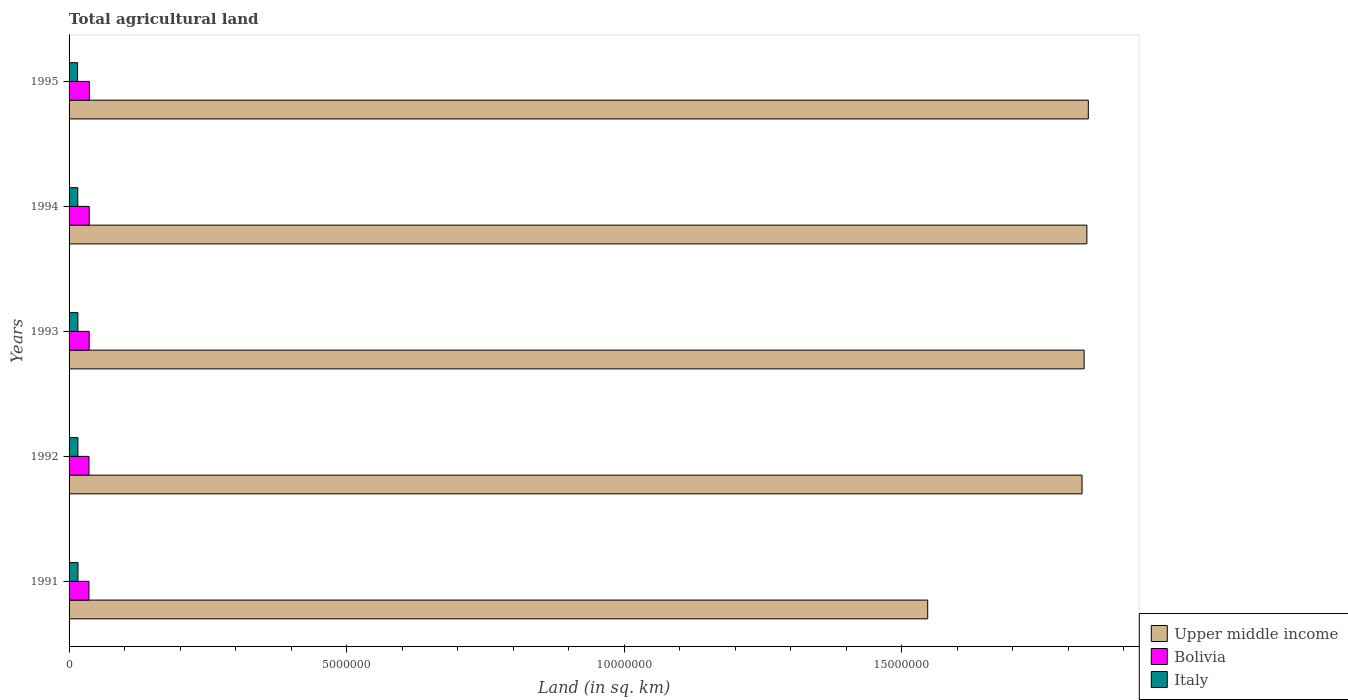How many different coloured bars are there?
Your response must be concise. 3. Are the number of bars on each tick of the Y-axis equal?
Offer a terse response. Yes. In how many cases, is the number of bars for a given year not equal to the number of legend labels?
Your answer should be compact. 0. What is the total agricultural land in Bolivia in 1992?
Offer a terse response. 3.58e+05. Across all years, what is the maximum total agricultural land in Italy?
Offer a very short reply. 1.61e+05. Across all years, what is the minimum total agricultural land in Italy?
Provide a succinct answer. 1.53e+05. In which year was the total agricultural land in Upper middle income maximum?
Your response must be concise. 1995. What is the total total agricultural land in Italy in the graph?
Offer a terse response. 7.90e+05. What is the difference between the total agricultural land in Bolivia in 1994 and that in 1995?
Offer a very short reply. -2490. What is the difference between the total agricultural land in Italy in 1993 and the total agricultural land in Upper middle income in 1994?
Offer a very short reply. -1.82e+07. What is the average total agricultural land in Italy per year?
Keep it short and to the point. 1.58e+05. In the year 1995, what is the difference between the total agricultural land in Upper middle income and total agricultural land in Bolivia?
Provide a short and direct response. 1.80e+07. In how many years, is the total agricultural land in Bolivia greater than 6000000 sq.km?
Ensure brevity in your answer.  0. What is the ratio of the total agricultural land in Bolivia in 1994 to that in 1995?
Your answer should be very brief. 0.99. Is the total agricultural land in Bolivia in 1992 less than that in 1993?
Provide a succinct answer. Yes. What is the difference between the highest and the second highest total agricultural land in Upper middle income?
Your answer should be compact. 2.58e+04. What is the difference between the highest and the lowest total agricultural land in Upper middle income?
Provide a short and direct response. 2.89e+06. Is the sum of the total agricultural land in Upper middle income in 1994 and 1995 greater than the maximum total agricultural land in Italy across all years?
Your response must be concise. Yes. What does the 1st bar from the top in 1992 represents?
Your response must be concise. Italy. Is it the case that in every year, the sum of the total agricultural land in Bolivia and total agricultural land in Italy is greater than the total agricultural land in Upper middle income?
Make the answer very short. No. Are all the bars in the graph horizontal?
Make the answer very short. Yes. What is the difference between two consecutive major ticks on the X-axis?
Your answer should be very brief. 5.00e+06. What is the title of the graph?
Your answer should be compact. Total agricultural land. Does "Myanmar" appear as one of the legend labels in the graph?
Your answer should be very brief. No. What is the label or title of the X-axis?
Provide a short and direct response. Land (in sq. km). What is the label or title of the Y-axis?
Make the answer very short. Years. What is the Land (in sq. km) of Upper middle income in 1991?
Make the answer very short. 1.55e+07. What is the Land (in sq. km) of Bolivia in 1991?
Provide a succinct answer. 3.58e+05. What is the Land (in sq. km) in Italy in 1991?
Your answer should be very brief. 1.61e+05. What is the Land (in sq. km) of Upper middle income in 1992?
Your answer should be very brief. 1.82e+07. What is the Land (in sq. km) of Bolivia in 1992?
Offer a terse response. 3.58e+05. What is the Land (in sq. km) in Italy in 1992?
Keep it short and to the point. 1.60e+05. What is the Land (in sq. km) of Upper middle income in 1993?
Your answer should be very brief. 1.83e+07. What is the Land (in sq. km) in Bolivia in 1993?
Your response must be concise. 3.62e+05. What is the Land (in sq. km) in Italy in 1993?
Your response must be concise. 1.59e+05. What is the Land (in sq. km) of Upper middle income in 1994?
Provide a short and direct response. 1.83e+07. What is the Land (in sq. km) of Bolivia in 1994?
Make the answer very short. 3.64e+05. What is the Land (in sq. km) in Italy in 1994?
Give a very brief answer. 1.57e+05. What is the Land (in sq. km) in Upper middle income in 1995?
Your response must be concise. 1.84e+07. What is the Land (in sq. km) in Bolivia in 1995?
Keep it short and to the point. 3.66e+05. What is the Land (in sq. km) in Italy in 1995?
Provide a succinct answer. 1.53e+05. Across all years, what is the maximum Land (in sq. km) in Upper middle income?
Keep it short and to the point. 1.84e+07. Across all years, what is the maximum Land (in sq. km) of Bolivia?
Your answer should be very brief. 3.66e+05. Across all years, what is the maximum Land (in sq. km) in Italy?
Your answer should be very brief. 1.61e+05. Across all years, what is the minimum Land (in sq. km) of Upper middle income?
Your answer should be compact. 1.55e+07. Across all years, what is the minimum Land (in sq. km) of Bolivia?
Your response must be concise. 3.58e+05. Across all years, what is the minimum Land (in sq. km) of Italy?
Make the answer very short. 1.53e+05. What is the total Land (in sq. km) in Upper middle income in the graph?
Your answer should be very brief. 8.87e+07. What is the total Land (in sq. km) in Bolivia in the graph?
Make the answer very short. 1.81e+06. What is the total Land (in sq. km) in Italy in the graph?
Your answer should be compact. 7.90e+05. What is the difference between the Land (in sq. km) of Upper middle income in 1991 and that in 1992?
Make the answer very short. -2.78e+06. What is the difference between the Land (in sq. km) in Bolivia in 1991 and that in 1992?
Offer a very short reply. -350. What is the difference between the Land (in sq. km) in Italy in 1991 and that in 1992?
Provide a short and direct response. 760. What is the difference between the Land (in sq. km) in Upper middle income in 1991 and that in 1993?
Ensure brevity in your answer.  -2.82e+06. What is the difference between the Land (in sq. km) of Bolivia in 1991 and that in 1993?
Provide a short and direct response. -4170. What is the difference between the Land (in sq. km) of Italy in 1991 and that in 1993?
Provide a succinct answer. 1440. What is the difference between the Land (in sq. km) of Upper middle income in 1991 and that in 1994?
Offer a terse response. -2.87e+06. What is the difference between the Land (in sq. km) of Bolivia in 1991 and that in 1994?
Keep it short and to the point. -5550. What is the difference between the Land (in sq. km) in Italy in 1991 and that in 1994?
Provide a succinct answer. 3520. What is the difference between the Land (in sq. km) in Upper middle income in 1991 and that in 1995?
Offer a very short reply. -2.89e+06. What is the difference between the Land (in sq. km) in Bolivia in 1991 and that in 1995?
Offer a terse response. -8040. What is the difference between the Land (in sq. km) of Italy in 1991 and that in 1995?
Your response must be concise. 7210. What is the difference between the Land (in sq. km) in Upper middle income in 1992 and that in 1993?
Offer a very short reply. -3.69e+04. What is the difference between the Land (in sq. km) of Bolivia in 1992 and that in 1993?
Make the answer very short. -3820. What is the difference between the Land (in sq. km) of Italy in 1992 and that in 1993?
Your answer should be very brief. 680. What is the difference between the Land (in sq. km) in Upper middle income in 1992 and that in 1994?
Give a very brief answer. -8.69e+04. What is the difference between the Land (in sq. km) in Bolivia in 1992 and that in 1994?
Keep it short and to the point. -5200. What is the difference between the Land (in sq. km) in Italy in 1992 and that in 1994?
Make the answer very short. 2760. What is the difference between the Land (in sq. km) in Upper middle income in 1992 and that in 1995?
Your answer should be compact. -1.13e+05. What is the difference between the Land (in sq. km) in Bolivia in 1992 and that in 1995?
Make the answer very short. -7690. What is the difference between the Land (in sq. km) in Italy in 1992 and that in 1995?
Give a very brief answer. 6450. What is the difference between the Land (in sq. km) of Upper middle income in 1993 and that in 1994?
Make the answer very short. -5.00e+04. What is the difference between the Land (in sq. km) in Bolivia in 1993 and that in 1994?
Provide a short and direct response. -1380. What is the difference between the Land (in sq. km) of Italy in 1993 and that in 1994?
Provide a short and direct response. 2080. What is the difference between the Land (in sq. km) in Upper middle income in 1993 and that in 1995?
Your answer should be compact. -7.58e+04. What is the difference between the Land (in sq. km) in Bolivia in 1993 and that in 1995?
Your answer should be compact. -3870. What is the difference between the Land (in sq. km) of Italy in 1993 and that in 1995?
Offer a very short reply. 5770. What is the difference between the Land (in sq. km) of Upper middle income in 1994 and that in 1995?
Your answer should be very brief. -2.58e+04. What is the difference between the Land (in sq. km) of Bolivia in 1994 and that in 1995?
Offer a very short reply. -2490. What is the difference between the Land (in sq. km) of Italy in 1994 and that in 1995?
Your answer should be compact. 3690. What is the difference between the Land (in sq. km) of Upper middle income in 1991 and the Land (in sq. km) of Bolivia in 1992?
Offer a terse response. 1.51e+07. What is the difference between the Land (in sq. km) of Upper middle income in 1991 and the Land (in sq. km) of Italy in 1992?
Your answer should be very brief. 1.53e+07. What is the difference between the Land (in sq. km) of Bolivia in 1991 and the Land (in sq. km) of Italy in 1992?
Provide a short and direct response. 1.98e+05. What is the difference between the Land (in sq. km) in Upper middle income in 1991 and the Land (in sq. km) in Bolivia in 1993?
Give a very brief answer. 1.51e+07. What is the difference between the Land (in sq. km) of Upper middle income in 1991 and the Land (in sq. km) of Italy in 1993?
Provide a succinct answer. 1.53e+07. What is the difference between the Land (in sq. km) in Bolivia in 1991 and the Land (in sq. km) in Italy in 1993?
Ensure brevity in your answer.  1.99e+05. What is the difference between the Land (in sq. km) in Upper middle income in 1991 and the Land (in sq. km) in Bolivia in 1994?
Provide a succinct answer. 1.51e+07. What is the difference between the Land (in sq. km) of Upper middle income in 1991 and the Land (in sq. km) of Italy in 1994?
Offer a very short reply. 1.53e+07. What is the difference between the Land (in sq. km) of Bolivia in 1991 and the Land (in sq. km) of Italy in 1994?
Keep it short and to the point. 2.01e+05. What is the difference between the Land (in sq. km) of Upper middle income in 1991 and the Land (in sq. km) of Bolivia in 1995?
Your answer should be very brief. 1.51e+07. What is the difference between the Land (in sq. km) in Upper middle income in 1991 and the Land (in sq. km) in Italy in 1995?
Make the answer very short. 1.53e+07. What is the difference between the Land (in sq. km) of Bolivia in 1991 and the Land (in sq. km) of Italy in 1995?
Offer a very short reply. 2.05e+05. What is the difference between the Land (in sq. km) of Upper middle income in 1992 and the Land (in sq. km) of Bolivia in 1993?
Make the answer very short. 1.79e+07. What is the difference between the Land (in sq. km) in Upper middle income in 1992 and the Land (in sq. km) in Italy in 1993?
Ensure brevity in your answer.  1.81e+07. What is the difference between the Land (in sq. km) of Bolivia in 1992 and the Land (in sq. km) of Italy in 1993?
Your answer should be very brief. 1.99e+05. What is the difference between the Land (in sq. km) of Upper middle income in 1992 and the Land (in sq. km) of Bolivia in 1994?
Offer a very short reply. 1.79e+07. What is the difference between the Land (in sq. km) in Upper middle income in 1992 and the Land (in sq. km) in Italy in 1994?
Your answer should be very brief. 1.81e+07. What is the difference between the Land (in sq. km) of Bolivia in 1992 and the Land (in sq. km) of Italy in 1994?
Ensure brevity in your answer.  2.01e+05. What is the difference between the Land (in sq. km) of Upper middle income in 1992 and the Land (in sq. km) of Bolivia in 1995?
Offer a very short reply. 1.79e+07. What is the difference between the Land (in sq. km) in Upper middle income in 1992 and the Land (in sq. km) in Italy in 1995?
Offer a very short reply. 1.81e+07. What is the difference between the Land (in sq. km) of Bolivia in 1992 and the Land (in sq. km) of Italy in 1995?
Your answer should be very brief. 2.05e+05. What is the difference between the Land (in sq. km) in Upper middle income in 1993 and the Land (in sq. km) in Bolivia in 1994?
Make the answer very short. 1.79e+07. What is the difference between the Land (in sq. km) in Upper middle income in 1993 and the Land (in sq. km) in Italy in 1994?
Offer a terse response. 1.81e+07. What is the difference between the Land (in sq. km) in Bolivia in 1993 and the Land (in sq. km) in Italy in 1994?
Provide a short and direct response. 2.05e+05. What is the difference between the Land (in sq. km) of Upper middle income in 1993 and the Land (in sq. km) of Bolivia in 1995?
Provide a short and direct response. 1.79e+07. What is the difference between the Land (in sq. km) of Upper middle income in 1993 and the Land (in sq. km) of Italy in 1995?
Your answer should be very brief. 1.81e+07. What is the difference between the Land (in sq. km) of Bolivia in 1993 and the Land (in sq. km) of Italy in 1995?
Your answer should be compact. 2.09e+05. What is the difference between the Land (in sq. km) in Upper middle income in 1994 and the Land (in sq. km) in Bolivia in 1995?
Offer a terse response. 1.80e+07. What is the difference between the Land (in sq. km) of Upper middle income in 1994 and the Land (in sq. km) of Italy in 1995?
Your response must be concise. 1.82e+07. What is the difference between the Land (in sq. km) in Bolivia in 1994 and the Land (in sq. km) in Italy in 1995?
Provide a succinct answer. 2.10e+05. What is the average Land (in sq. km) of Upper middle income per year?
Offer a terse response. 1.77e+07. What is the average Land (in sq. km) in Bolivia per year?
Offer a very short reply. 3.62e+05. What is the average Land (in sq. km) of Italy per year?
Keep it short and to the point. 1.58e+05. In the year 1991, what is the difference between the Land (in sq. km) in Upper middle income and Land (in sq. km) in Bolivia?
Give a very brief answer. 1.51e+07. In the year 1991, what is the difference between the Land (in sq. km) of Upper middle income and Land (in sq. km) of Italy?
Offer a terse response. 1.53e+07. In the year 1991, what is the difference between the Land (in sq. km) in Bolivia and Land (in sq. km) in Italy?
Your response must be concise. 1.97e+05. In the year 1992, what is the difference between the Land (in sq. km) of Upper middle income and Land (in sq. km) of Bolivia?
Offer a terse response. 1.79e+07. In the year 1992, what is the difference between the Land (in sq. km) in Upper middle income and Land (in sq. km) in Italy?
Offer a terse response. 1.81e+07. In the year 1992, what is the difference between the Land (in sq. km) in Bolivia and Land (in sq. km) in Italy?
Offer a very short reply. 1.99e+05. In the year 1993, what is the difference between the Land (in sq. km) in Upper middle income and Land (in sq. km) in Bolivia?
Provide a short and direct response. 1.79e+07. In the year 1993, what is the difference between the Land (in sq. km) in Upper middle income and Land (in sq. km) in Italy?
Offer a very short reply. 1.81e+07. In the year 1993, what is the difference between the Land (in sq. km) in Bolivia and Land (in sq. km) in Italy?
Offer a very short reply. 2.03e+05. In the year 1994, what is the difference between the Land (in sq. km) in Upper middle income and Land (in sq. km) in Bolivia?
Your response must be concise. 1.80e+07. In the year 1994, what is the difference between the Land (in sq. km) of Upper middle income and Land (in sq. km) of Italy?
Offer a very short reply. 1.82e+07. In the year 1994, what is the difference between the Land (in sq. km) of Bolivia and Land (in sq. km) of Italy?
Your response must be concise. 2.06e+05. In the year 1995, what is the difference between the Land (in sq. km) in Upper middle income and Land (in sq. km) in Bolivia?
Offer a very short reply. 1.80e+07. In the year 1995, what is the difference between the Land (in sq. km) in Upper middle income and Land (in sq. km) in Italy?
Make the answer very short. 1.82e+07. In the year 1995, what is the difference between the Land (in sq. km) of Bolivia and Land (in sq. km) of Italy?
Your answer should be very brief. 2.13e+05. What is the ratio of the Land (in sq. km) of Upper middle income in 1991 to that in 1992?
Ensure brevity in your answer.  0.85. What is the ratio of the Land (in sq. km) of Bolivia in 1991 to that in 1992?
Your answer should be compact. 1. What is the ratio of the Land (in sq. km) of Upper middle income in 1991 to that in 1993?
Make the answer very short. 0.85. What is the ratio of the Land (in sq. km) in Bolivia in 1991 to that in 1993?
Your answer should be very brief. 0.99. What is the ratio of the Land (in sq. km) of Italy in 1991 to that in 1993?
Offer a very short reply. 1.01. What is the ratio of the Land (in sq. km) of Upper middle income in 1991 to that in 1994?
Provide a short and direct response. 0.84. What is the ratio of the Land (in sq. km) in Bolivia in 1991 to that in 1994?
Provide a succinct answer. 0.98. What is the ratio of the Land (in sq. km) of Italy in 1991 to that in 1994?
Ensure brevity in your answer.  1.02. What is the ratio of the Land (in sq. km) in Upper middle income in 1991 to that in 1995?
Give a very brief answer. 0.84. What is the ratio of the Land (in sq. km) in Bolivia in 1991 to that in 1995?
Ensure brevity in your answer.  0.98. What is the ratio of the Land (in sq. km) of Italy in 1991 to that in 1995?
Your answer should be very brief. 1.05. What is the ratio of the Land (in sq. km) in Italy in 1992 to that in 1993?
Provide a short and direct response. 1. What is the ratio of the Land (in sq. km) in Upper middle income in 1992 to that in 1994?
Give a very brief answer. 1. What is the ratio of the Land (in sq. km) of Bolivia in 1992 to that in 1994?
Your answer should be compact. 0.99. What is the ratio of the Land (in sq. km) of Italy in 1992 to that in 1994?
Offer a terse response. 1.02. What is the ratio of the Land (in sq. km) in Bolivia in 1992 to that in 1995?
Provide a short and direct response. 0.98. What is the ratio of the Land (in sq. km) in Italy in 1992 to that in 1995?
Keep it short and to the point. 1.04. What is the ratio of the Land (in sq. km) in Italy in 1993 to that in 1994?
Offer a terse response. 1.01. What is the ratio of the Land (in sq. km) in Bolivia in 1993 to that in 1995?
Make the answer very short. 0.99. What is the ratio of the Land (in sq. km) of Italy in 1993 to that in 1995?
Offer a terse response. 1.04. What is the ratio of the Land (in sq. km) of Upper middle income in 1994 to that in 1995?
Ensure brevity in your answer.  1. What is the ratio of the Land (in sq. km) in Bolivia in 1994 to that in 1995?
Your answer should be very brief. 0.99. What is the ratio of the Land (in sq. km) in Italy in 1994 to that in 1995?
Your answer should be compact. 1.02. What is the difference between the highest and the second highest Land (in sq. km) of Upper middle income?
Offer a terse response. 2.58e+04. What is the difference between the highest and the second highest Land (in sq. km) of Bolivia?
Give a very brief answer. 2490. What is the difference between the highest and the second highest Land (in sq. km) in Italy?
Your answer should be compact. 760. What is the difference between the highest and the lowest Land (in sq. km) in Upper middle income?
Your answer should be very brief. 2.89e+06. What is the difference between the highest and the lowest Land (in sq. km) in Bolivia?
Your response must be concise. 8040. What is the difference between the highest and the lowest Land (in sq. km) in Italy?
Offer a terse response. 7210. 